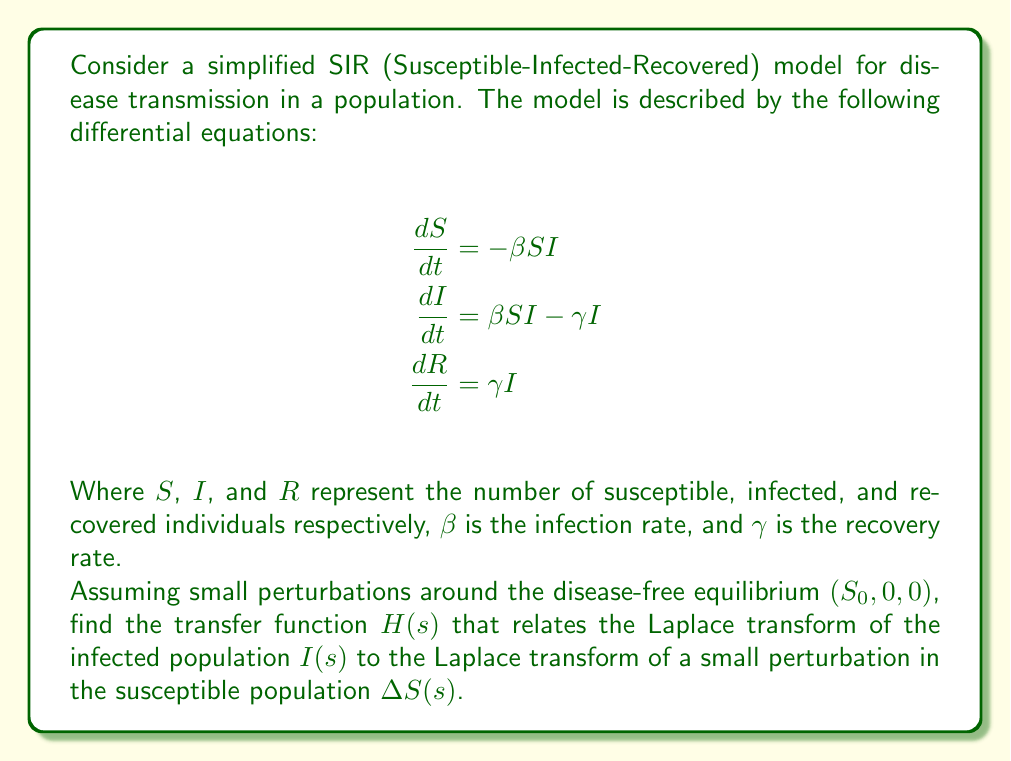Provide a solution to this math problem. To find the transfer function, we need to linearize the system around the disease-free equilibrium and then apply the Laplace transform. Let's go through this step-by-step:

1) Linearize the system:
   At the disease-free equilibrium, $S = S_0$, $I = 0$, $R = 0$. Let $\Delta S$, $\Delta I$, and $\Delta R$ be small perturbations around this equilibrium.

   $$\frac{d(\Delta S)}{dt} \approx -\beta S_0 \Delta I$$
   $$\frac{d(\Delta I)}{dt} \approx \beta S_0 \Delta I - \gamma \Delta I = (\beta S_0 - \gamma) \Delta I$$
   $$\frac{d(\Delta R)}{dt} \approx \gamma \Delta I$$

2) We're interested in the relationship between $\Delta S$ and $\Delta I$, so we'll focus on the first two equations.

3) Apply the Laplace transform to these equations:
   $$s\Delta S(s) = -\beta S_0 \Delta I(s)$$
   $$s\Delta I(s) = (\beta S_0 - \gamma) \Delta I(s)$$

4) From the second equation:
   $$\Delta I(s) [s - (\beta S_0 - \gamma)] = 0$$
   $$\Delta I(s) = 0$$ or $$s = \beta S_0 - \gamma$$

5) The transfer function $H(s)$ is defined as:
   $$H(s) = \frac{\Delta I(s)}{\Delta S(s)}$$

6) From the first Laplace transformed equation:
   $$\Delta I(s) = -\frac{s}{\beta S_0} \Delta S(s)$$

7) Therefore, the transfer function is:
   $$H(s) = -\frac{s}{\beta S_0}$$

This transfer function represents how small changes in the susceptible population affect the infected population in the Laplace domain.
Answer: $$H(s) = -\frac{s}{\beta S_0}$$ 